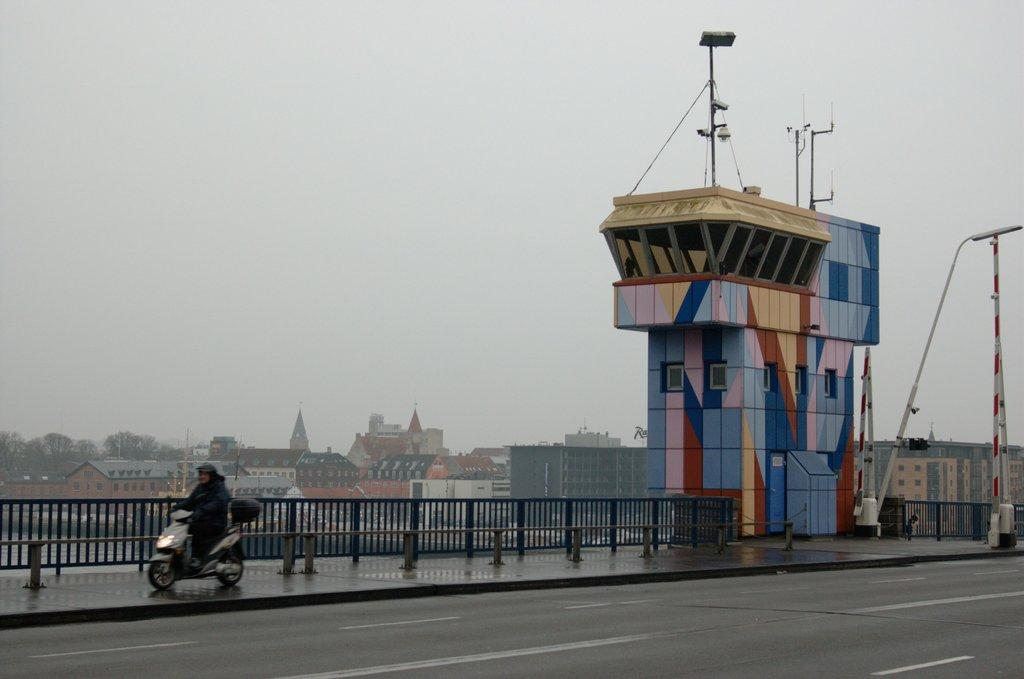What is the person in the image doing? There is a person riding a bike in the image. What type of path is the person riding on? This is a road. What is located near the road? There is a fence near the road. What can be seen in the distance in the image? There are buildings, trees, poles, and the sky visible in the background. What type of soda is being advertised on the fence in the image? There is no soda or advertisement present on the fence in the image. How many tomatoes are growing on the trees in the background? There are no tomatoes visible on the trees in the background; only trees are present. 